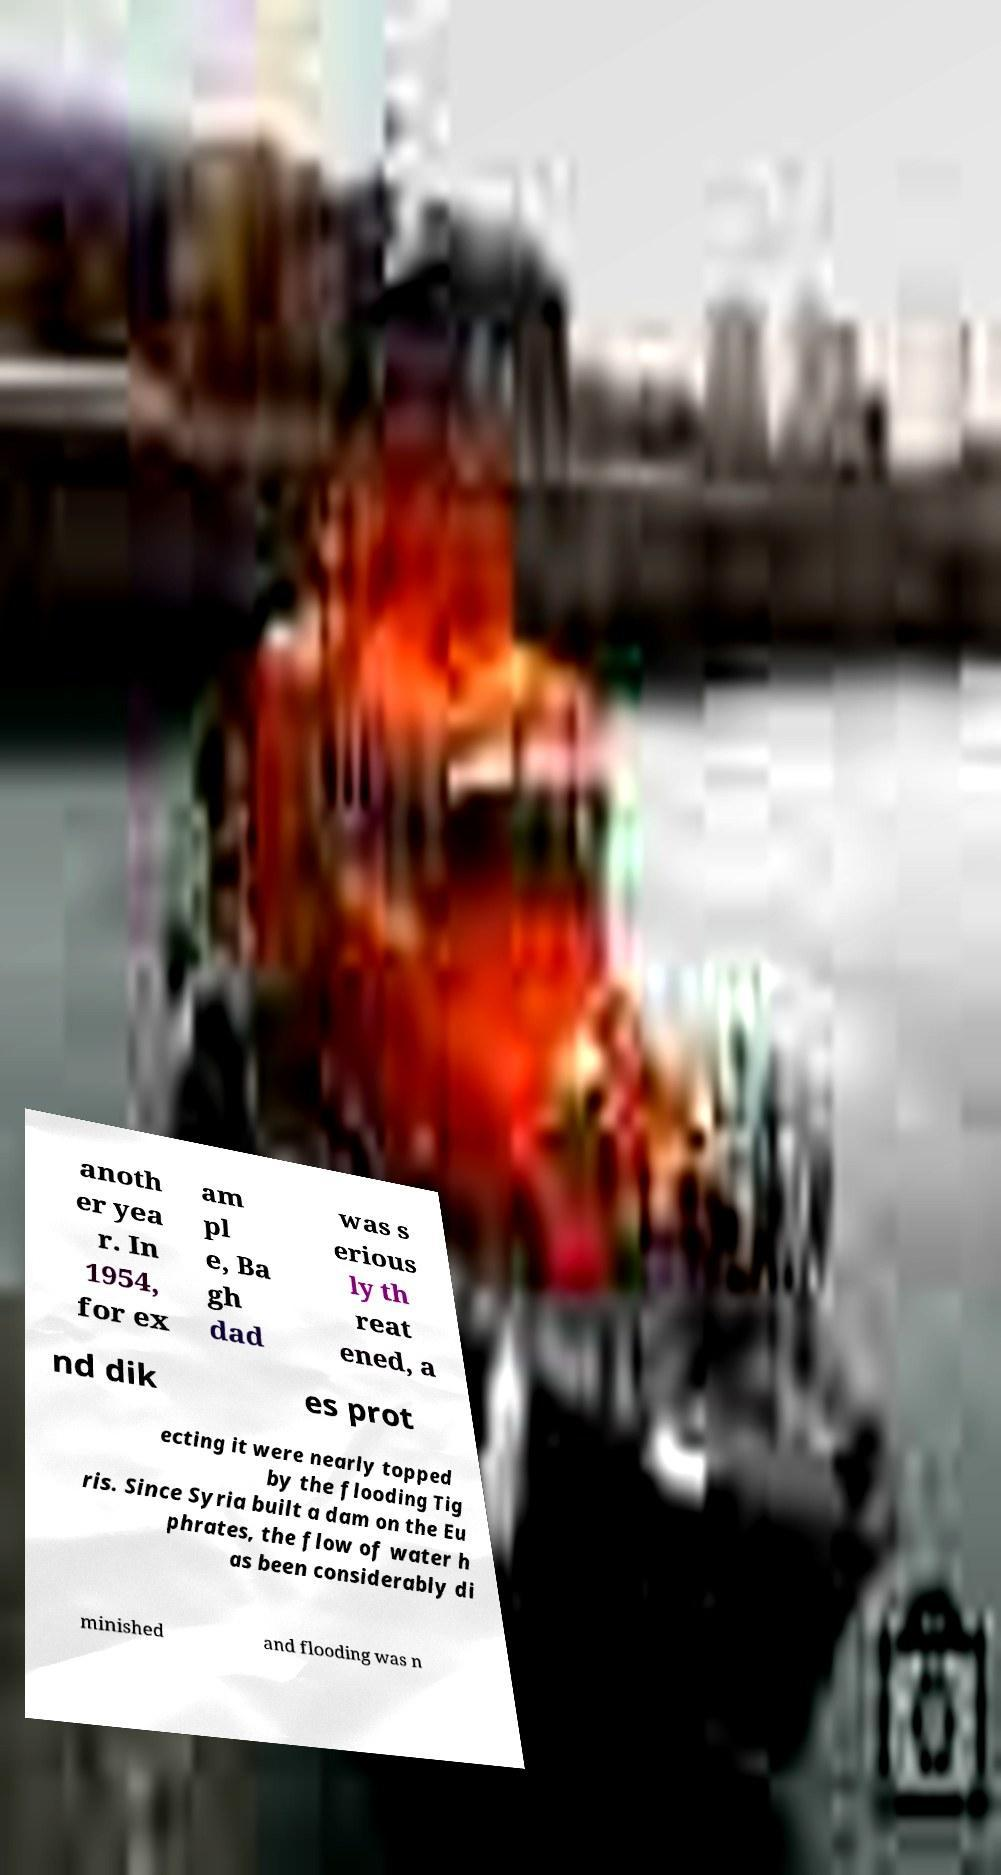For documentation purposes, I need the text within this image transcribed. Could you provide that? anoth er yea r. In 1954, for ex am pl e, Ba gh dad was s erious ly th reat ened, a nd dik es prot ecting it were nearly topped by the flooding Tig ris. Since Syria built a dam on the Eu phrates, the flow of water h as been considerably di minished and flooding was n 